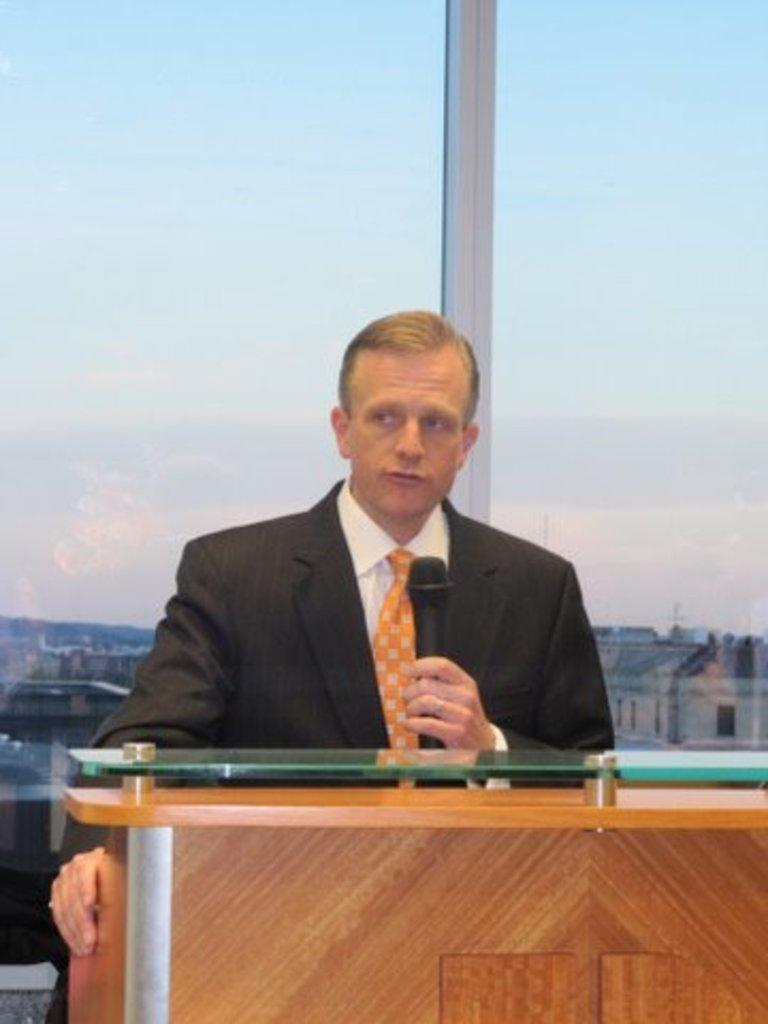What is the main subject of the image? There is a man in the image. What is the man doing in the image? The man is standing and speaking on a microphone. What is behind the man in the image? There is a glass wall behind the man. What can be seen in the background of the image? The sky is visible in the image. What type of authority does the man have in the image? There is no indication of the man's authority in the image. What angle is the image taken from? The angle from which the image is taken is not mentioned in the provided facts. 